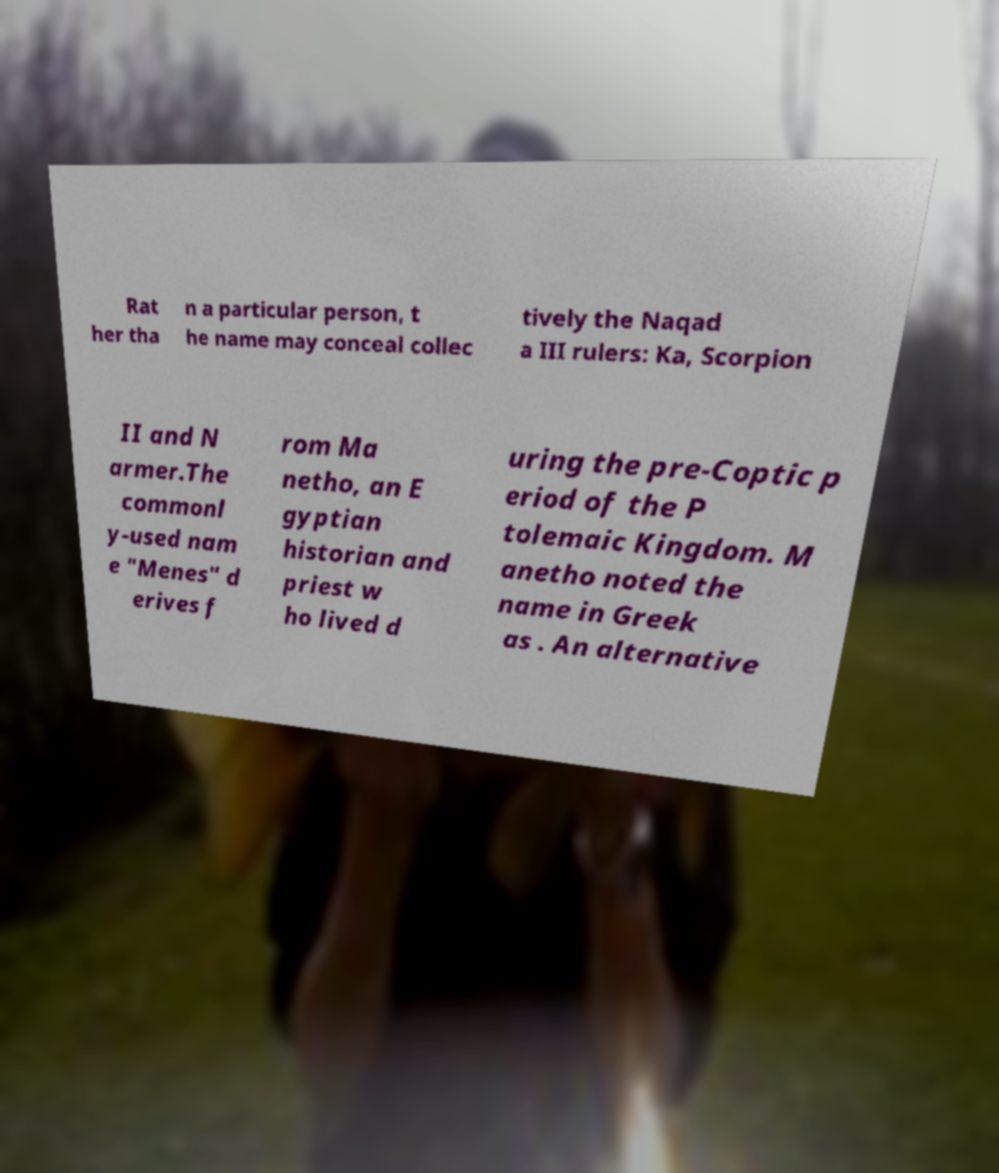Can you accurately transcribe the text from the provided image for me? Rat her tha n a particular person, t he name may conceal collec tively the Naqad a III rulers: Ka, Scorpion II and N armer.The commonl y-used nam e "Menes" d erives f rom Ma netho, an E gyptian historian and priest w ho lived d uring the pre-Coptic p eriod of the P tolemaic Kingdom. M anetho noted the name in Greek as . An alternative 